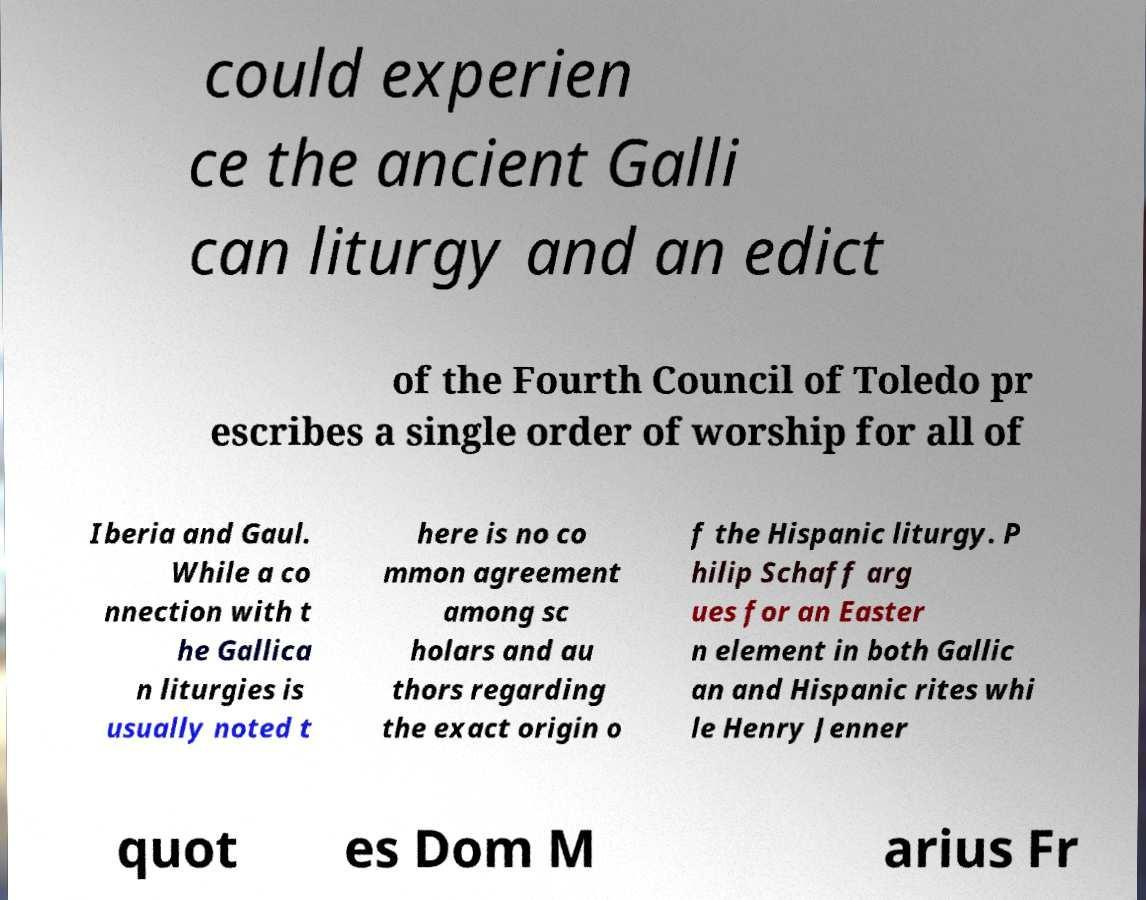For documentation purposes, I need the text within this image transcribed. Could you provide that? could experien ce the ancient Galli can liturgy and an edict of the Fourth Council of Toledo pr escribes a single order of worship for all of Iberia and Gaul. While a co nnection with t he Gallica n liturgies is usually noted t here is no co mmon agreement among sc holars and au thors regarding the exact origin o f the Hispanic liturgy. P hilip Schaff arg ues for an Easter n element in both Gallic an and Hispanic rites whi le Henry Jenner quot es Dom M arius Fr 